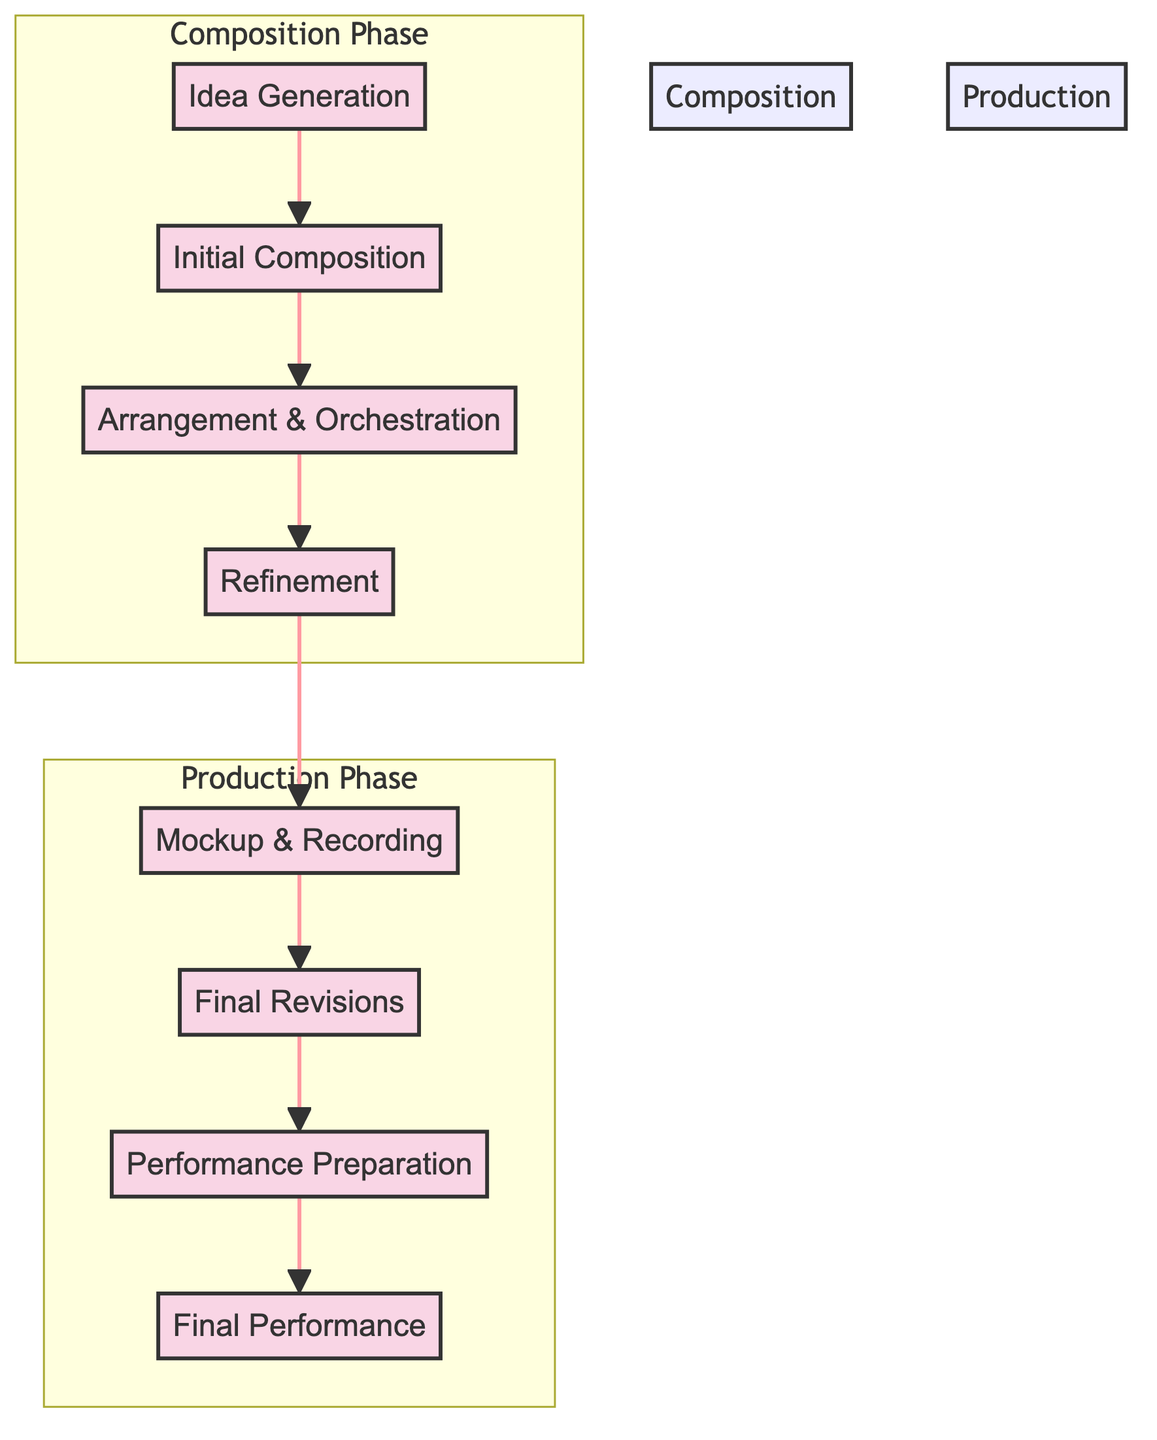What is the first block in the workflow? The first block in the workflow is labeled "Idea Generation". This is evident as it is the starting point connected to the following block.
Answer: Idea Generation How many blocks are there in total? The diagram comprises eight distinct blocks, each representing a stage in the composition process. This can be counted directly from the visual representation.
Answer: Eight Which block comes after "Initial Composition"? The block that follows "Initial Composition" in the workflow is "Arrangement & Orchestration". This is indicated by the direct arrow connecting the two blocks.
Answer: Arrangement & Orchestration What are the two main phases in the diagram? The two main phases represented in the diagram are "Composition Phase" and "Production Phase". These are grouped visually with distinct colors and labeled as subgraphs.
Answer: Composition Phase, Production Phase How does "Refinement" relate to "Mockup & Recording"? "Refinement" directly precedes "Mockup & Recording" in the flow of the diagram, indicating that the refinement stage must be completed before moving on to the mockup and recording.
Answer: Sequentially connected Which block involves using virtual instruments? The block that involves using virtual instruments is "Mockup & Recording". This step specifically mentions the creation of recordings using virtual instruments.
Answer: Mockup & Recording What is the final step before the performance of the symphony? The step that occurs immediately before the performance of the symphony is "Performance Preparation". This is the last stage leading to the actual performance or recording.
Answer: Performance Preparation How many steps are listed under "Arrangement & Orchestration"? There are three steps listed under the "Arrangement & Orchestration" block. This can be verified by counting the bullet points provided in that block's description.
Answer: Three 